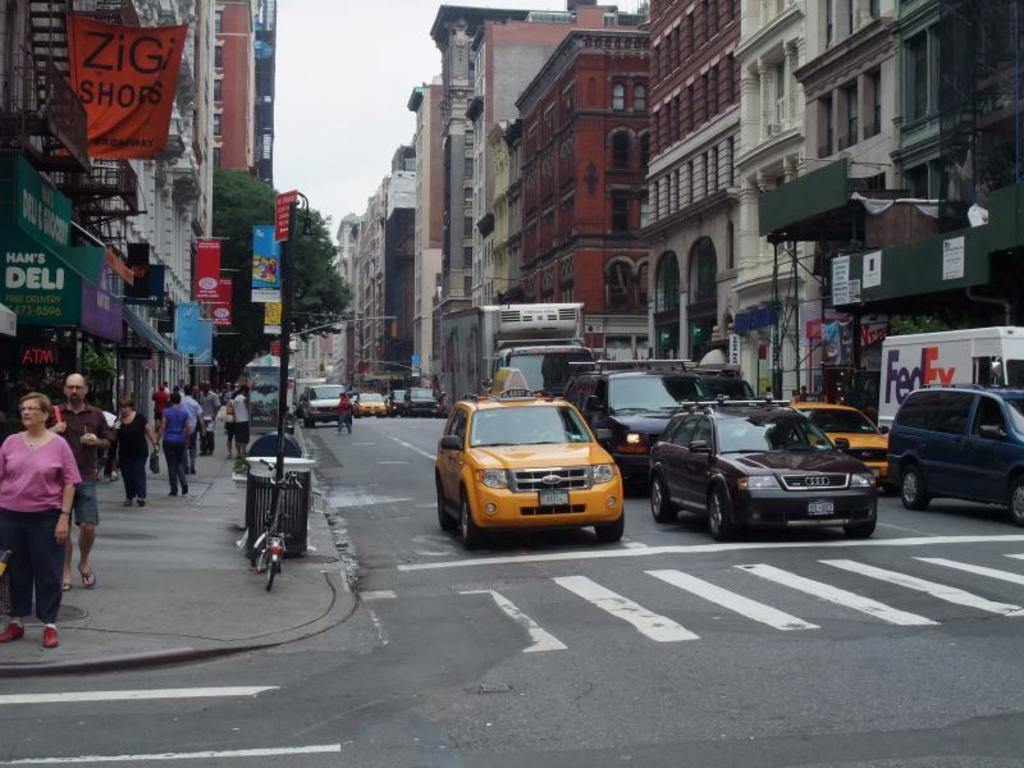<image>
Offer a succinct explanation of the picture presented. the word zig on an orange sign that is outside 